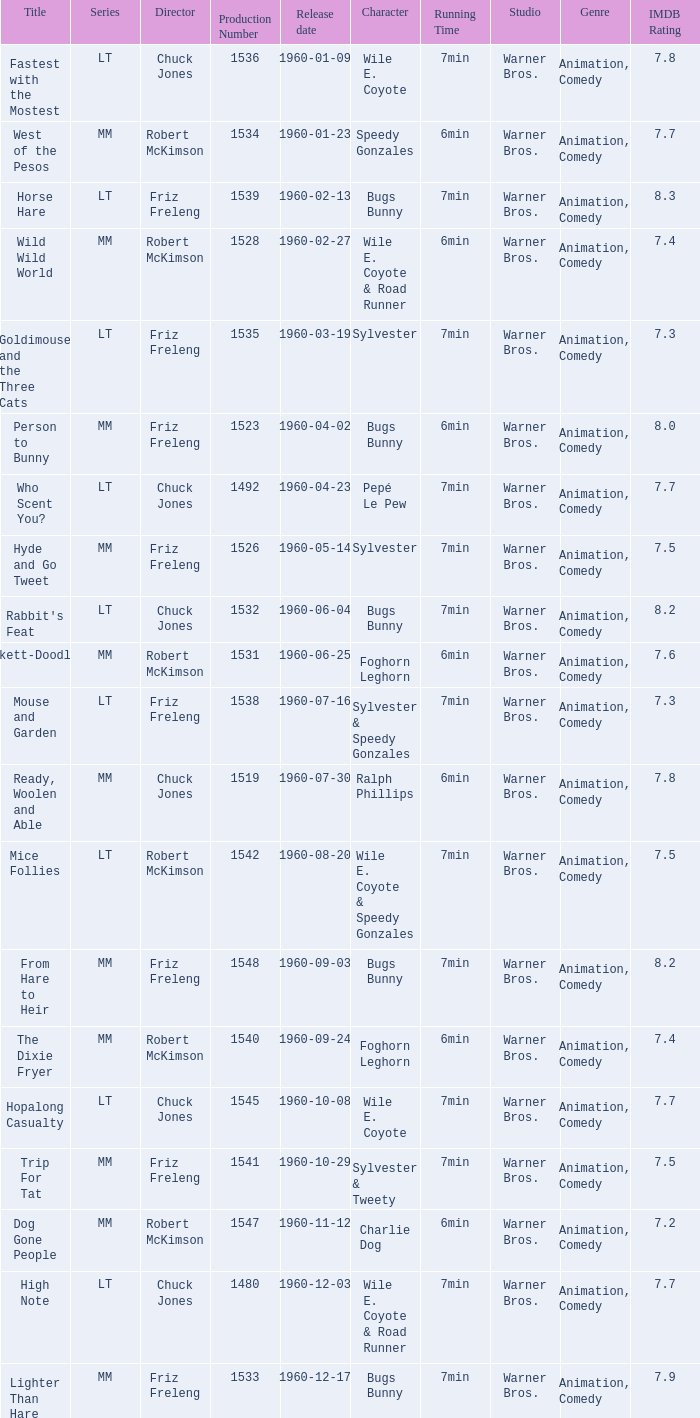What is the production number for the episode directed by Robert McKimson named Mice Follies? 1.0. 